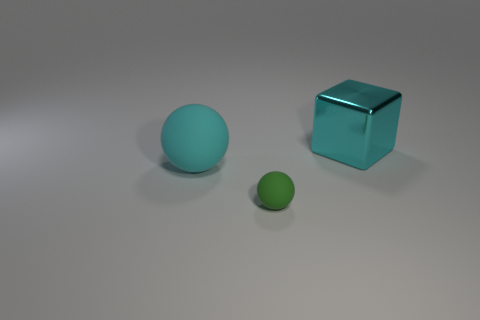Do the cyan object left of the metallic object and the big shiny object have the same shape?
Provide a short and direct response. No. There is a big object behind the large cyan rubber thing; what material is it?
Offer a very short reply. Metal. There is a rubber object that is the same color as the big metallic block; what is its shape?
Your answer should be very brief. Sphere. Is there a big cyan thing that has the same material as the big ball?
Your answer should be very brief. No. The green object is what size?
Your answer should be compact. Small. What number of yellow objects are either blocks or tiny balls?
Ensure brevity in your answer.  0. How many green matte objects have the same shape as the metal thing?
Your answer should be very brief. 0. How many things are the same size as the green ball?
Your answer should be compact. 0. There is a green object that is the same shape as the large cyan rubber object; what is its material?
Provide a succinct answer. Rubber. There is a big object that is in front of the big metallic object; what color is it?
Provide a short and direct response. Cyan. 